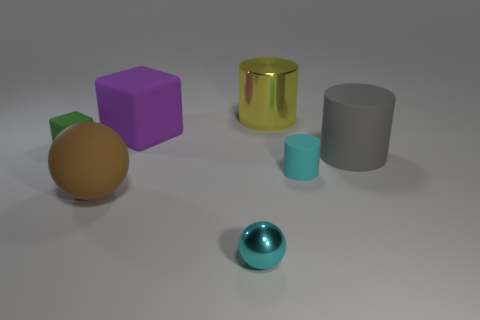Add 3 big cyan things. How many objects exist? 10 Subtract all spheres. How many objects are left? 5 Add 6 large purple spheres. How many large purple spheres exist? 6 Subtract 0 brown cylinders. How many objects are left? 7 Subtract all big gray matte objects. Subtract all green matte things. How many objects are left? 5 Add 6 purple cubes. How many purple cubes are left? 7 